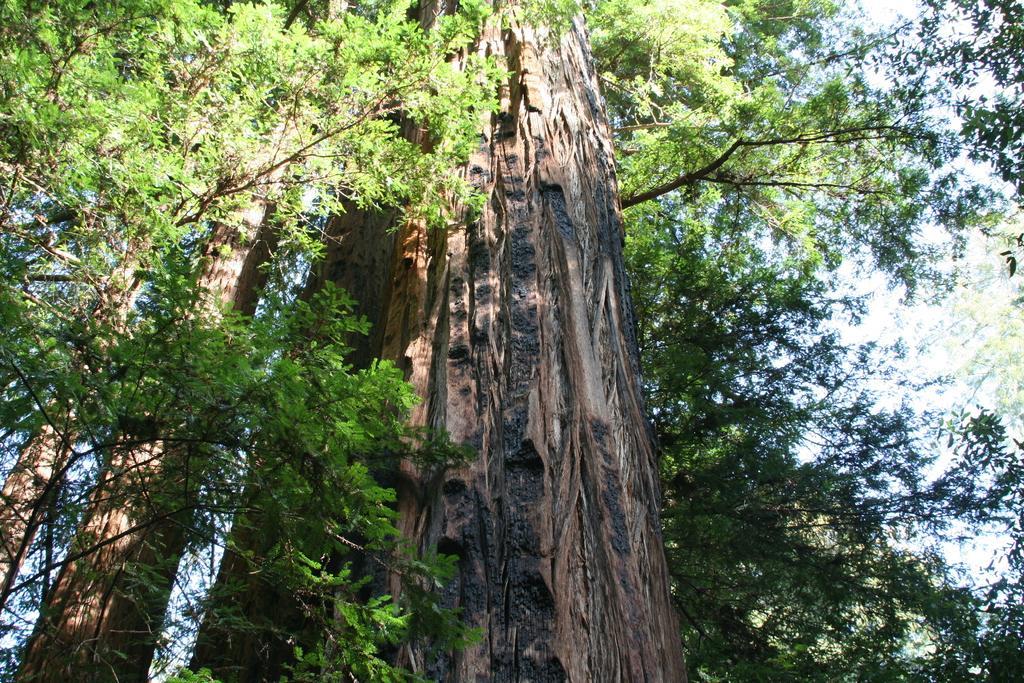How would you summarize this image in a sentence or two? In this image we can see many trees. We can see the sky in the image. 